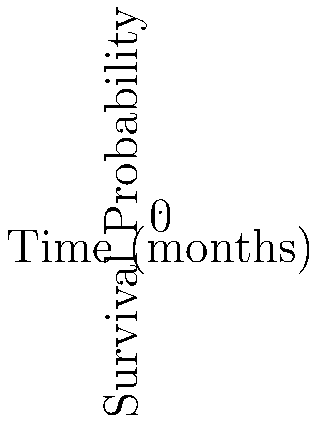Based on the Kaplan-Meier survival curves shown for two treatments in a population-based study, what can be concluded about the efficacy of Treatment A compared to Treatment B after 36 months? How would you quantify this difference? To interpret and compare the Kaplan-Meier survival curves for Treatments A and B, we need to follow these steps:

1. Observe the overall trend: Both curves show a decreasing survival probability over time, which is expected in most survival analyses.

2. Compare the curves: Treatment A (blue line) consistently shows a higher survival probability than Treatment B (red line) throughout the 36-month period.

3. Assess the difference at the end of the study period (36 months):
   - Treatment A: Survival probability ≈ 0.55 (55%)
   - Treatment B: Survival probability ≈ 0.40 (40%)

4. Calculate the absolute risk reduction (ARR):
   ARR = Survival probability of Treatment A - Survival probability of Treatment B
   ARR ≈ 0.55 - 0.40 = 0.15 (15%)

5. Calculate the relative risk reduction (RRR):
   RRR = (Survival probability of Treatment A - Survival probability of Treatment B) / Survival probability of Treatment B
   RRR ≈ (0.55 - 0.40) / 0.40 = 0.375 (37.5%)

6. Calculate the number needed to treat (NNT):
   NNT = 1 / ARR
   NNT ≈ 1 / 0.15 ≈ 6.67

Based on these calculations, we can conclude that Treatment A is more efficacious than Treatment B in improving survival rates over a 36-month period. The absolute risk reduction of 15% indicates a clinically significant improvement. The relative risk reduction of 37.5% suggests that Treatment A reduces the risk of the event (in this case, death) by more than one-third compared to Treatment B. The number needed to treat of approximately 7 implies that for every 7 patients treated with Treatment A instead of Treatment B, one additional death would be prevented over 36 months.
Answer: Treatment A is more efficacious, with a 15% absolute risk reduction and 37.5% relative risk reduction in mortality at 36 months compared to Treatment B. 